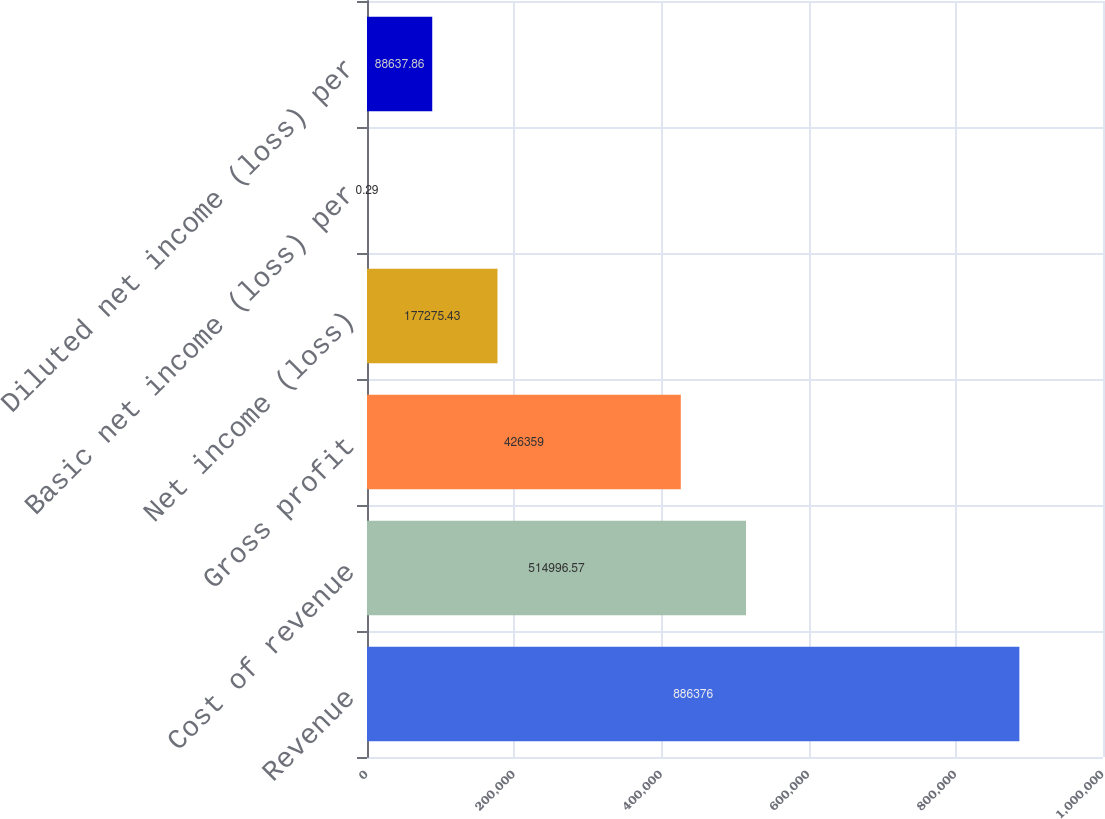<chart> <loc_0><loc_0><loc_500><loc_500><bar_chart><fcel>Revenue<fcel>Cost of revenue<fcel>Gross profit<fcel>Net income (loss)<fcel>Basic net income (loss) per<fcel>Diluted net income (loss) per<nl><fcel>886376<fcel>514997<fcel>426359<fcel>177275<fcel>0.29<fcel>88637.9<nl></chart> 